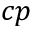Convert formula to latex. <formula><loc_0><loc_0><loc_500><loc_500>c p</formula> 